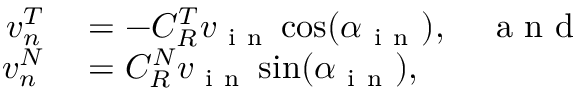Convert formula to latex. <formula><loc_0><loc_0><loc_500><loc_500>\begin{array} { r l } { v _ { n } ^ { T } } & = - C _ { R } ^ { T } v _ { i n } \cos ( \alpha _ { i n } ) , \quad a n d } \\ { v _ { n } ^ { N } } & = C _ { R } ^ { N } v _ { i n } \sin ( \alpha _ { i n } ) , } \end{array}</formula> 